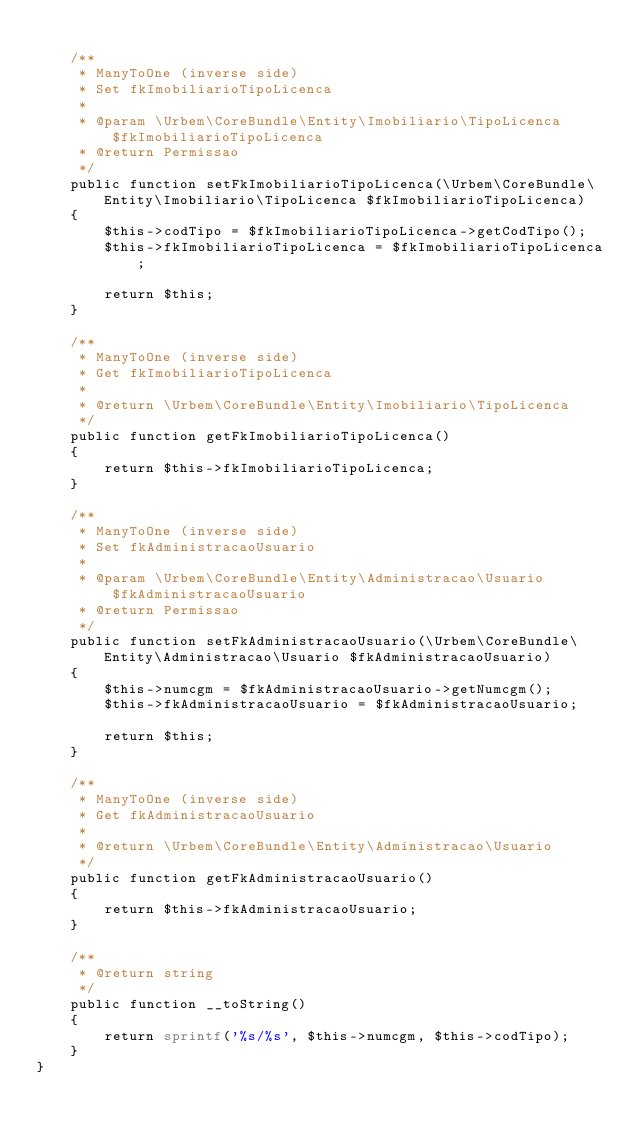Convert code to text. <code><loc_0><loc_0><loc_500><loc_500><_PHP_>
    /**
     * ManyToOne (inverse side)
     * Set fkImobiliarioTipoLicenca
     *
     * @param \Urbem\CoreBundle\Entity\Imobiliario\TipoLicenca $fkImobiliarioTipoLicenca
     * @return Permissao
     */
    public function setFkImobiliarioTipoLicenca(\Urbem\CoreBundle\Entity\Imobiliario\TipoLicenca $fkImobiliarioTipoLicenca)
    {
        $this->codTipo = $fkImobiliarioTipoLicenca->getCodTipo();
        $this->fkImobiliarioTipoLicenca = $fkImobiliarioTipoLicenca;
        
        return $this;
    }

    /**
     * ManyToOne (inverse side)
     * Get fkImobiliarioTipoLicenca
     *
     * @return \Urbem\CoreBundle\Entity\Imobiliario\TipoLicenca
     */
    public function getFkImobiliarioTipoLicenca()
    {
        return $this->fkImobiliarioTipoLicenca;
    }

    /**
     * ManyToOne (inverse side)
     * Set fkAdministracaoUsuario
     *
     * @param \Urbem\CoreBundle\Entity\Administracao\Usuario $fkAdministracaoUsuario
     * @return Permissao
     */
    public function setFkAdministracaoUsuario(\Urbem\CoreBundle\Entity\Administracao\Usuario $fkAdministracaoUsuario)
    {
        $this->numcgm = $fkAdministracaoUsuario->getNumcgm();
        $this->fkAdministracaoUsuario = $fkAdministracaoUsuario;
        
        return $this;
    }

    /**
     * ManyToOne (inverse side)
     * Get fkAdministracaoUsuario
     *
     * @return \Urbem\CoreBundle\Entity\Administracao\Usuario
     */
    public function getFkAdministracaoUsuario()
    {
        return $this->fkAdministracaoUsuario;
    }

    /**
     * @return string
     */
    public function __toString()
    {
        return sprintf('%s/%s', $this->numcgm, $this->codTipo);
    }
}
</code> 